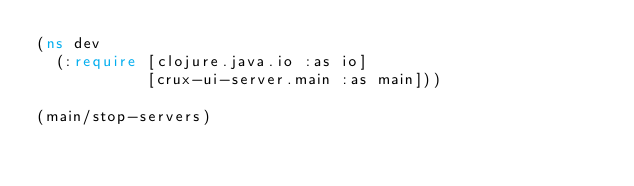Convert code to text. <code><loc_0><loc_0><loc_500><loc_500><_Clojure_>(ns dev
  (:require [clojure.java.io :as io]
            [crux-ui-server.main :as main]))

(main/stop-servers)</code> 